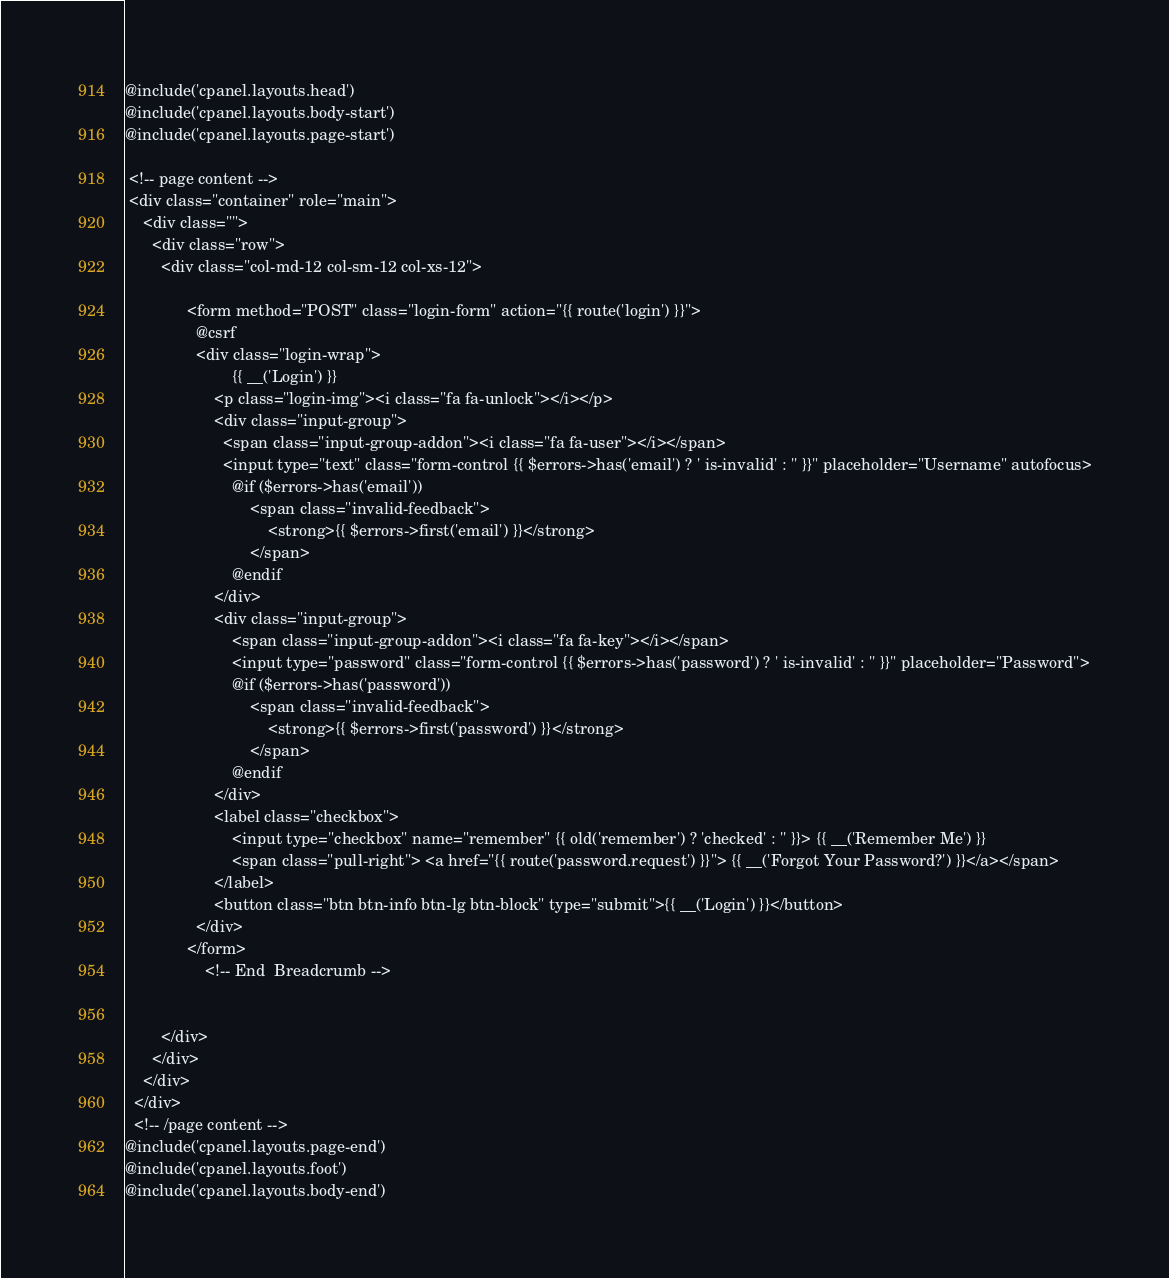<code> <loc_0><loc_0><loc_500><loc_500><_PHP_>@include('cpanel.layouts.head')
@include('cpanel.layouts.body-start')
@include('cpanel.layouts.page-start')

 <!-- page content -->
 <div class="container" role="main">
    <div class="">
      <div class="row">
        <div class="col-md-12 col-sm-12 col-xs-12">

              <form method="POST" class="login-form" action="{{ route('login') }}">
                @csrf
                <div class="login-wrap">
                        {{ __('Login') }}
                    <p class="login-img"><i class="fa fa-unlock"></i></p>
                    <div class="input-group">
                      <span class="input-group-addon"><i class="fa fa-user"></i></span>
                      <input type="text" class="form-control {{ $errors->has('email') ? ' is-invalid' : '' }}" placeholder="Username" autofocus>
                        @if ($errors->has('email'))
                            <span class="invalid-feedback">
                                <strong>{{ $errors->first('email') }}</strong>
                            </span>
                        @endif
                    </div>
                    <div class="input-group">
                        <span class="input-group-addon"><i class="fa fa-key"></i></span>
                        <input type="password" class="form-control {{ $errors->has('password') ? ' is-invalid' : '' }}" placeholder="Password">
                        @if ($errors->has('password'))
                            <span class="invalid-feedback">
                                <strong>{{ $errors->first('password') }}</strong>
                            </span>
                        @endif
                    </div>
                    <label class="checkbox">
                        <input type="checkbox" name="remember" {{ old('remember') ? 'checked' : '' }}> {{ __('Remember Me') }}
                        <span class="pull-right"> <a href="{{ route('password.request') }}"> {{ __('Forgot Your Password?') }}</a></span>
                    </label>
                    <button class="btn btn-info btn-lg btn-block" type="submit">{{ __('Login') }}</button>
                </div>
              </form>
                  <!-- End  Breadcrumb -->


        </div>
      </div>
    </div>
  </div>
  <!-- /page content -->
@include('cpanel.layouts.page-end')
@include('cpanel.layouts.foot')
@include('cpanel.layouts.body-end')
</code> 